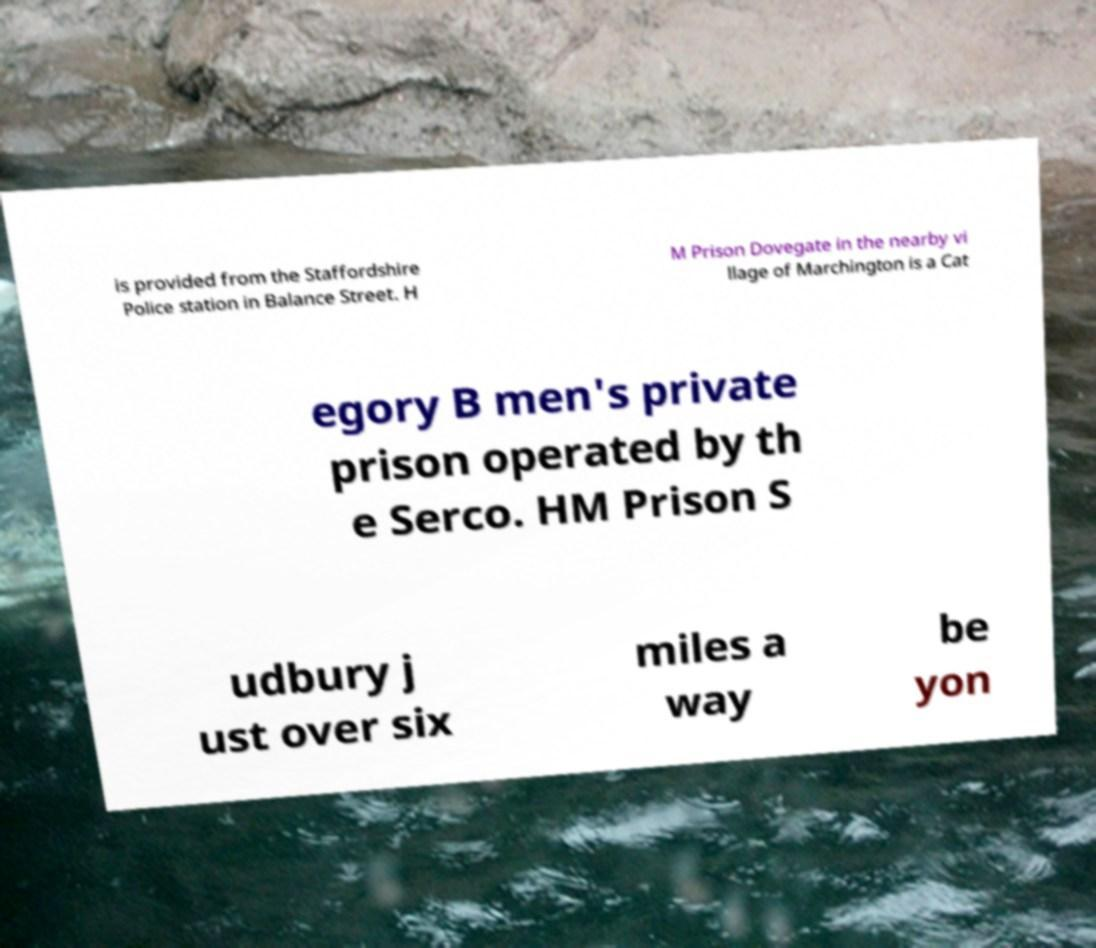Can you read and provide the text displayed in the image?This photo seems to have some interesting text. Can you extract and type it out for me? is provided from the Staffordshire Police station in Balance Street. H M Prison Dovegate in the nearby vi llage of Marchington is a Cat egory B men's private prison operated by th e Serco. HM Prison S udbury j ust over six miles a way be yon 